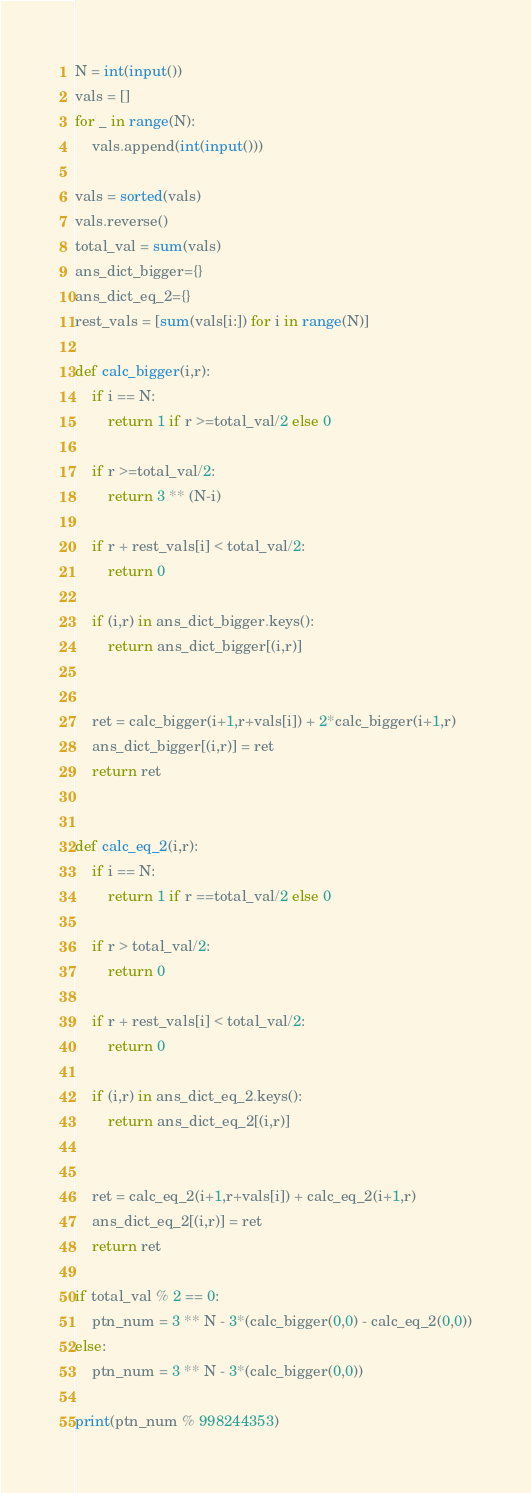Convert code to text. <code><loc_0><loc_0><loc_500><loc_500><_Python_>N = int(input())
vals = []
for _ in range(N):
	vals.append(int(input()))

vals = sorted(vals)
vals.reverse()
total_val = sum(vals)
ans_dict_bigger={}
ans_dict_eq_2={}
rest_vals = [sum(vals[i:]) for i in range(N)]

def calc_bigger(i,r):
	if i == N:
		return 1 if r >=total_val/2 else 0
	
	if r >=total_val/2:
		return 3 ** (N-i)
	
	if r + rest_vals[i] < total_val/2:
		return 0
	
	if (i,r) in ans_dict_bigger.keys():
		return ans_dict_bigger[(i,r)]
	

	ret = calc_bigger(i+1,r+vals[i]) + 2*calc_bigger(i+1,r)
	ans_dict_bigger[(i,r)] = ret
	return ret


def calc_eq_2(i,r):
	if i == N:
		return 1 if r ==total_val/2 else 0
	
	if r > total_val/2:
		return 0
	
	if r + rest_vals[i] < total_val/2:
		return 0
	
	if (i,r) in ans_dict_eq_2.keys():
		return ans_dict_eq_2[(i,r)]
	

	ret = calc_eq_2(i+1,r+vals[i]) + calc_eq_2(i+1,r)
	ans_dict_eq_2[(i,r)] = ret
	return ret

if total_val % 2 == 0:
	ptn_num = 3 ** N - 3*(calc_bigger(0,0) - calc_eq_2(0,0))
else:
	ptn_num = 3 ** N - 3*(calc_bigger(0,0))

print(ptn_num % 998244353)</code> 